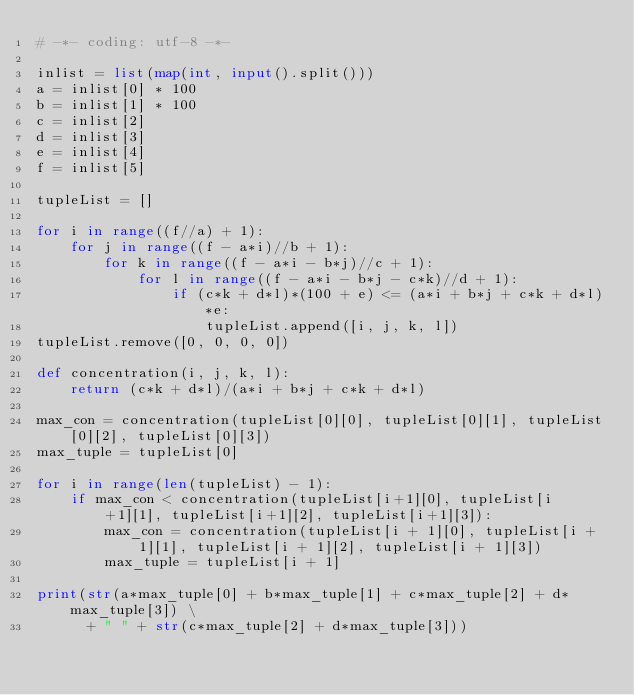<code> <loc_0><loc_0><loc_500><loc_500><_Python_># -*- coding: utf-8 -*-

inlist = list(map(int, input().split()))
a = inlist[0] * 100
b = inlist[1] * 100
c = inlist[2]
d = inlist[3]
e = inlist[4]
f = inlist[5]

tupleList = []

for i in range((f//a) + 1):
    for j in range((f - a*i)//b + 1):
        for k in range((f - a*i - b*j)//c + 1):
            for l in range((f - a*i - b*j - c*k)//d + 1):
                if (c*k + d*l)*(100 + e) <= (a*i + b*j + c*k + d*l)*e:
                    tupleList.append([i, j, k, l])
tupleList.remove([0, 0, 0, 0])

def concentration(i, j, k, l):
    return (c*k + d*l)/(a*i + b*j + c*k + d*l)

max_con = concentration(tupleList[0][0], tupleList[0][1], tupleList[0][2], tupleList[0][3])
max_tuple = tupleList[0]

for i in range(len(tupleList) - 1):
    if max_con < concentration(tupleList[i+1][0], tupleList[i+1][1], tupleList[i+1][2], tupleList[i+1][3]):
        max_con = concentration(tupleList[i + 1][0], tupleList[i + 1][1], tupleList[i + 1][2], tupleList[i + 1][3])
        max_tuple = tupleList[i + 1]

print(str(a*max_tuple[0] + b*max_tuple[1] + c*max_tuple[2] + d*max_tuple[3]) \
      + " " + str(c*max_tuple[2] + d*max_tuple[3]))
</code> 